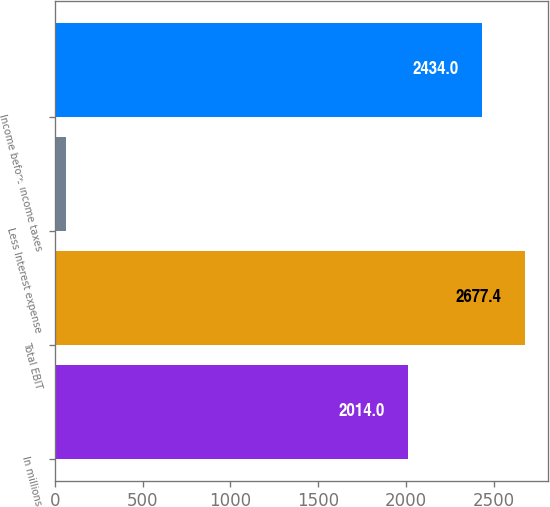Convert chart to OTSL. <chart><loc_0><loc_0><loc_500><loc_500><bar_chart><fcel>In millions<fcel>Total EBIT<fcel>Less Interest expense<fcel>Income before income taxes<nl><fcel>2014<fcel>2677.4<fcel>64<fcel>2434<nl></chart> 